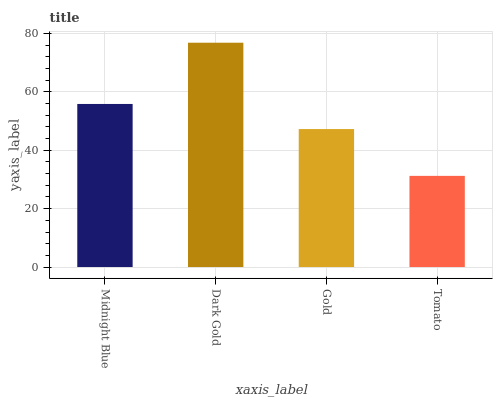Is Tomato the minimum?
Answer yes or no. Yes. Is Dark Gold the maximum?
Answer yes or no. Yes. Is Gold the minimum?
Answer yes or no. No. Is Gold the maximum?
Answer yes or no. No. Is Dark Gold greater than Gold?
Answer yes or no. Yes. Is Gold less than Dark Gold?
Answer yes or no. Yes. Is Gold greater than Dark Gold?
Answer yes or no. No. Is Dark Gold less than Gold?
Answer yes or no. No. Is Midnight Blue the high median?
Answer yes or no. Yes. Is Gold the low median?
Answer yes or no. Yes. Is Tomato the high median?
Answer yes or no. No. Is Midnight Blue the low median?
Answer yes or no. No. 